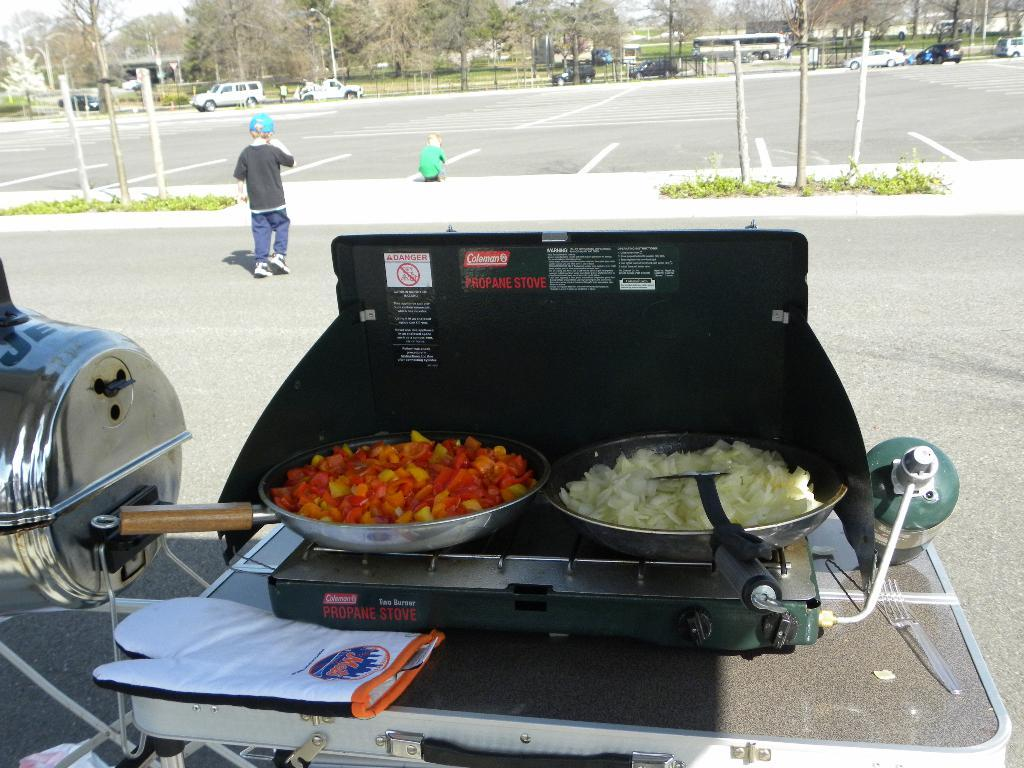<image>
Share a concise interpretation of the image provided. A grill from the company Coleman with tomatoes and onions 